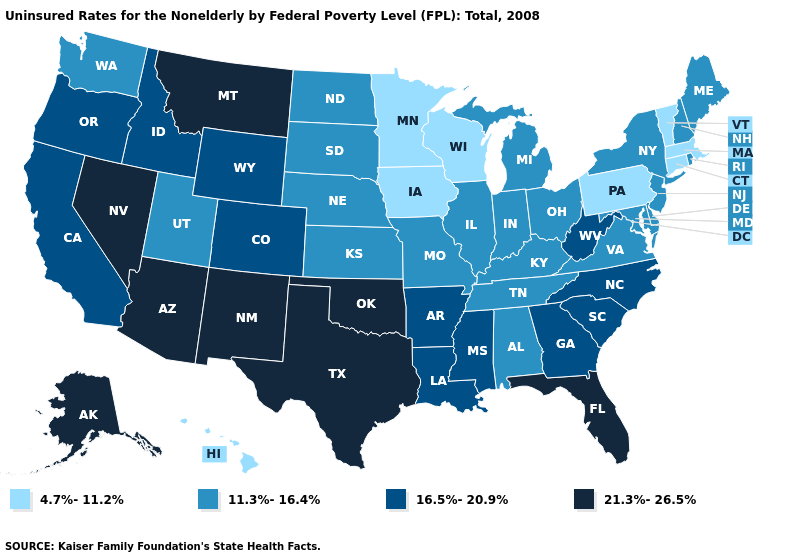Which states hav the highest value in the West?
Quick response, please. Alaska, Arizona, Montana, Nevada, New Mexico. What is the value of New York?
Be succinct. 11.3%-16.4%. Does Delaware have a lower value than Nebraska?
Quick response, please. No. Name the states that have a value in the range 11.3%-16.4%?
Quick response, please. Alabama, Delaware, Illinois, Indiana, Kansas, Kentucky, Maine, Maryland, Michigan, Missouri, Nebraska, New Hampshire, New Jersey, New York, North Dakota, Ohio, Rhode Island, South Dakota, Tennessee, Utah, Virginia, Washington. What is the value of Arkansas?
Write a very short answer. 16.5%-20.9%. Does Maine have the lowest value in the Northeast?
Keep it brief. No. Name the states that have a value in the range 4.7%-11.2%?
Answer briefly. Connecticut, Hawaii, Iowa, Massachusetts, Minnesota, Pennsylvania, Vermont, Wisconsin. Among the states that border Nebraska , which have the lowest value?
Be succinct. Iowa. Does Minnesota have the highest value in the MidWest?
Give a very brief answer. No. What is the value of Oklahoma?
Write a very short answer. 21.3%-26.5%. Is the legend a continuous bar?
Answer briefly. No. Does Alabama have the highest value in the USA?
Keep it brief. No. What is the value of Iowa?
Quick response, please. 4.7%-11.2%. What is the value of Alabama?
Be succinct. 11.3%-16.4%. 